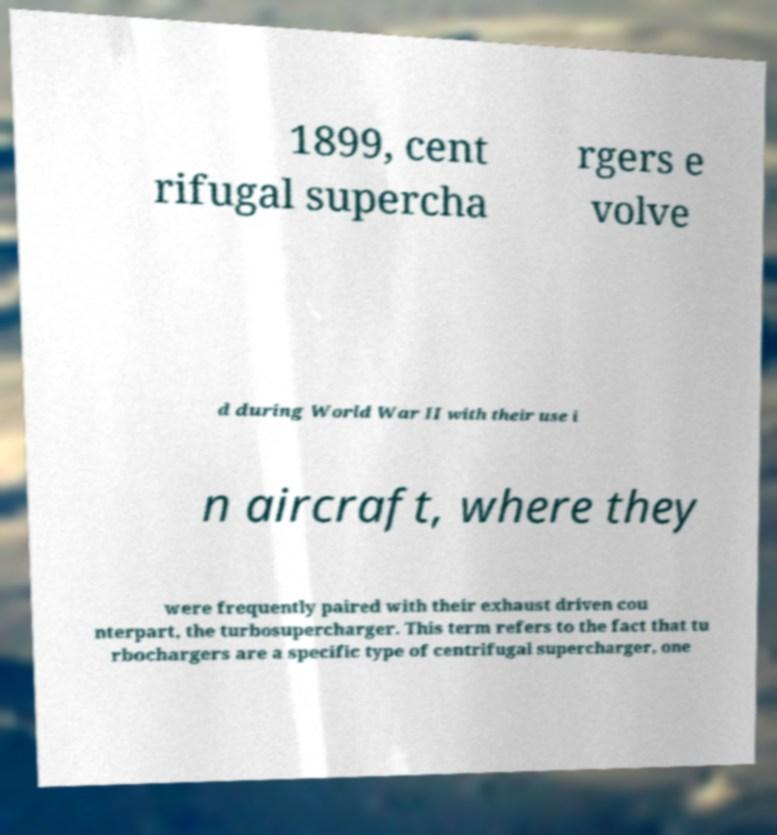For documentation purposes, I need the text within this image transcribed. Could you provide that? 1899, cent rifugal supercha rgers e volve d during World War II with their use i n aircraft, where they were frequently paired with their exhaust driven cou nterpart, the turbosupercharger. This term refers to the fact that tu rbochargers are a specific type of centrifugal supercharger, one 